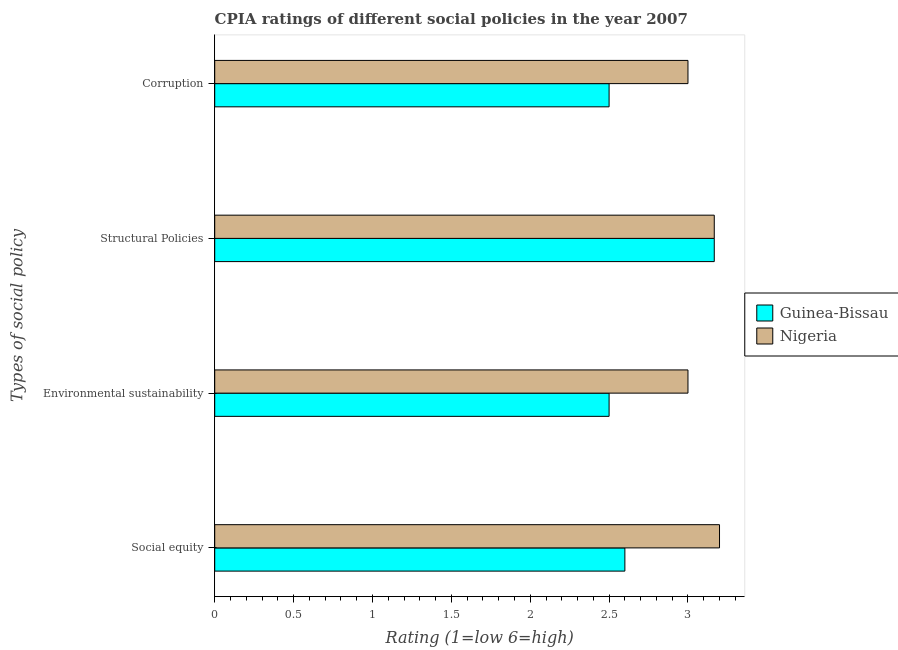How many groups of bars are there?
Your response must be concise. 4. How many bars are there on the 3rd tick from the top?
Provide a succinct answer. 2. What is the label of the 3rd group of bars from the top?
Provide a short and direct response. Environmental sustainability. Across all countries, what is the minimum cpia rating of structural policies?
Make the answer very short. 3.17. In which country was the cpia rating of structural policies maximum?
Make the answer very short. Guinea-Bissau. In which country was the cpia rating of environmental sustainability minimum?
Your answer should be compact. Guinea-Bissau. What is the difference between the cpia rating of environmental sustainability in Nigeria and that in Guinea-Bissau?
Make the answer very short. 0.5. What is the difference between the cpia rating of social equity in Guinea-Bissau and the cpia rating of structural policies in Nigeria?
Your answer should be compact. -0.57. What is the average cpia rating of structural policies per country?
Your answer should be compact. 3.17. What is the difference between the cpia rating of corruption and cpia rating of social equity in Nigeria?
Your answer should be very brief. -0.2. Is the cpia rating of social equity in Nigeria less than that in Guinea-Bissau?
Offer a very short reply. No. Is the difference between the cpia rating of corruption in Guinea-Bissau and Nigeria greater than the difference between the cpia rating of structural policies in Guinea-Bissau and Nigeria?
Offer a terse response. No. What is the difference between the highest and the lowest cpia rating of structural policies?
Give a very brief answer. 0. Is the sum of the cpia rating of corruption in Guinea-Bissau and Nigeria greater than the maximum cpia rating of structural policies across all countries?
Your answer should be compact. Yes. Is it the case that in every country, the sum of the cpia rating of environmental sustainability and cpia rating of corruption is greater than the sum of cpia rating of structural policies and cpia rating of social equity?
Your answer should be very brief. No. What does the 2nd bar from the top in Corruption represents?
Keep it short and to the point. Guinea-Bissau. What does the 2nd bar from the bottom in Environmental sustainability represents?
Keep it short and to the point. Nigeria. How many bars are there?
Ensure brevity in your answer.  8. Are all the bars in the graph horizontal?
Offer a very short reply. Yes. What is the difference between two consecutive major ticks on the X-axis?
Your answer should be very brief. 0.5. Are the values on the major ticks of X-axis written in scientific E-notation?
Ensure brevity in your answer.  No. How many legend labels are there?
Ensure brevity in your answer.  2. How are the legend labels stacked?
Ensure brevity in your answer.  Vertical. What is the title of the graph?
Your answer should be compact. CPIA ratings of different social policies in the year 2007. What is the label or title of the X-axis?
Provide a succinct answer. Rating (1=low 6=high). What is the label or title of the Y-axis?
Your response must be concise. Types of social policy. What is the Rating (1=low 6=high) in Guinea-Bissau in Social equity?
Provide a succinct answer. 2.6. What is the Rating (1=low 6=high) in Nigeria in Social equity?
Provide a succinct answer. 3.2. What is the Rating (1=low 6=high) in Guinea-Bissau in Structural Policies?
Give a very brief answer. 3.17. What is the Rating (1=low 6=high) in Nigeria in Structural Policies?
Give a very brief answer. 3.17. What is the Rating (1=low 6=high) in Guinea-Bissau in Corruption?
Provide a short and direct response. 2.5. What is the Rating (1=low 6=high) in Nigeria in Corruption?
Ensure brevity in your answer.  3. Across all Types of social policy, what is the maximum Rating (1=low 6=high) in Guinea-Bissau?
Your response must be concise. 3.17. Across all Types of social policy, what is the minimum Rating (1=low 6=high) of Guinea-Bissau?
Your answer should be very brief. 2.5. Across all Types of social policy, what is the minimum Rating (1=low 6=high) of Nigeria?
Offer a terse response. 3. What is the total Rating (1=low 6=high) in Guinea-Bissau in the graph?
Your answer should be very brief. 10.77. What is the total Rating (1=low 6=high) of Nigeria in the graph?
Provide a succinct answer. 12.37. What is the difference between the Rating (1=low 6=high) of Guinea-Bissau in Social equity and that in Structural Policies?
Offer a terse response. -0.57. What is the difference between the Rating (1=low 6=high) in Nigeria in Social equity and that in Structural Policies?
Your response must be concise. 0.03. What is the difference between the Rating (1=low 6=high) of Guinea-Bissau in Social equity and that in Corruption?
Give a very brief answer. 0.1. What is the difference between the Rating (1=low 6=high) in Nigeria in Social equity and that in Corruption?
Ensure brevity in your answer.  0.2. What is the difference between the Rating (1=low 6=high) in Guinea-Bissau in Environmental sustainability and that in Structural Policies?
Your answer should be compact. -0.67. What is the difference between the Rating (1=low 6=high) of Guinea-Bissau in Environmental sustainability and that in Corruption?
Keep it short and to the point. 0. What is the difference between the Rating (1=low 6=high) in Nigeria in Structural Policies and that in Corruption?
Provide a succinct answer. 0.17. What is the difference between the Rating (1=low 6=high) in Guinea-Bissau in Social equity and the Rating (1=low 6=high) in Nigeria in Structural Policies?
Keep it short and to the point. -0.57. What is the difference between the Rating (1=low 6=high) in Guinea-Bissau in Social equity and the Rating (1=low 6=high) in Nigeria in Corruption?
Offer a terse response. -0.4. What is the difference between the Rating (1=low 6=high) of Guinea-Bissau in Environmental sustainability and the Rating (1=low 6=high) of Nigeria in Structural Policies?
Keep it short and to the point. -0.67. What is the difference between the Rating (1=low 6=high) in Guinea-Bissau in Structural Policies and the Rating (1=low 6=high) in Nigeria in Corruption?
Provide a succinct answer. 0.17. What is the average Rating (1=low 6=high) of Guinea-Bissau per Types of social policy?
Make the answer very short. 2.69. What is the average Rating (1=low 6=high) in Nigeria per Types of social policy?
Keep it short and to the point. 3.09. What is the difference between the Rating (1=low 6=high) of Guinea-Bissau and Rating (1=low 6=high) of Nigeria in Social equity?
Give a very brief answer. -0.6. What is the difference between the Rating (1=low 6=high) of Guinea-Bissau and Rating (1=low 6=high) of Nigeria in Environmental sustainability?
Your answer should be very brief. -0.5. What is the ratio of the Rating (1=low 6=high) of Nigeria in Social equity to that in Environmental sustainability?
Provide a short and direct response. 1.07. What is the ratio of the Rating (1=low 6=high) of Guinea-Bissau in Social equity to that in Structural Policies?
Give a very brief answer. 0.82. What is the ratio of the Rating (1=low 6=high) in Nigeria in Social equity to that in Structural Policies?
Ensure brevity in your answer.  1.01. What is the ratio of the Rating (1=low 6=high) in Guinea-Bissau in Social equity to that in Corruption?
Provide a short and direct response. 1.04. What is the ratio of the Rating (1=low 6=high) in Nigeria in Social equity to that in Corruption?
Your answer should be very brief. 1.07. What is the ratio of the Rating (1=low 6=high) in Guinea-Bissau in Environmental sustainability to that in Structural Policies?
Your response must be concise. 0.79. What is the ratio of the Rating (1=low 6=high) in Guinea-Bissau in Structural Policies to that in Corruption?
Your response must be concise. 1.27. What is the ratio of the Rating (1=low 6=high) of Nigeria in Structural Policies to that in Corruption?
Offer a terse response. 1.06. What is the difference between the highest and the second highest Rating (1=low 6=high) in Guinea-Bissau?
Your answer should be very brief. 0.57. What is the difference between the highest and the lowest Rating (1=low 6=high) of Guinea-Bissau?
Make the answer very short. 0.67. 